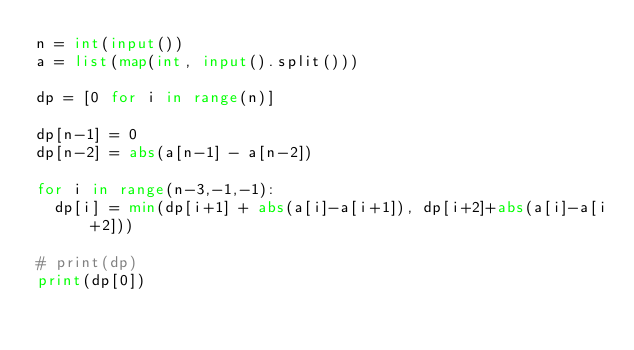Convert code to text. <code><loc_0><loc_0><loc_500><loc_500><_Python_>n = int(input())
a = list(map(int, input().split()))

dp = [0 for i in range(n)]

dp[n-1] = 0
dp[n-2] = abs(a[n-1] - a[n-2])

for i in range(n-3,-1,-1):
	dp[i] = min(dp[i+1] + abs(a[i]-a[i+1]), dp[i+2]+abs(a[i]-a[i+2]))

# print(dp)
print(dp[0])</code> 